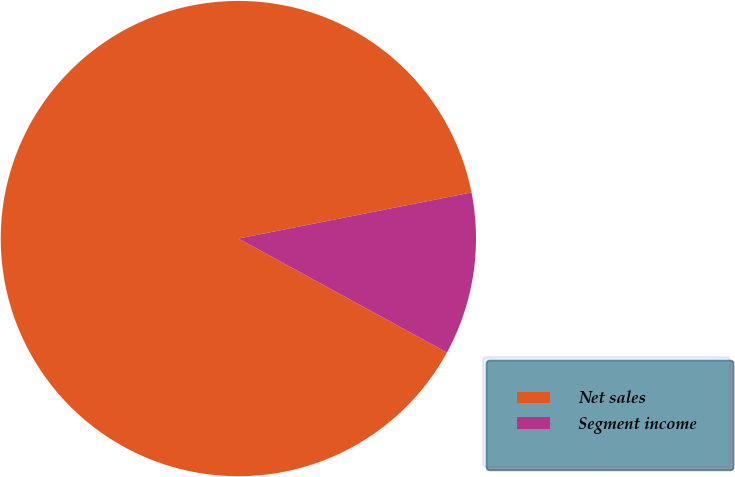Convert chart. <chart><loc_0><loc_0><loc_500><loc_500><pie_chart><fcel>Net sales<fcel>Segment income<nl><fcel>88.93%<fcel>11.07%<nl></chart> 